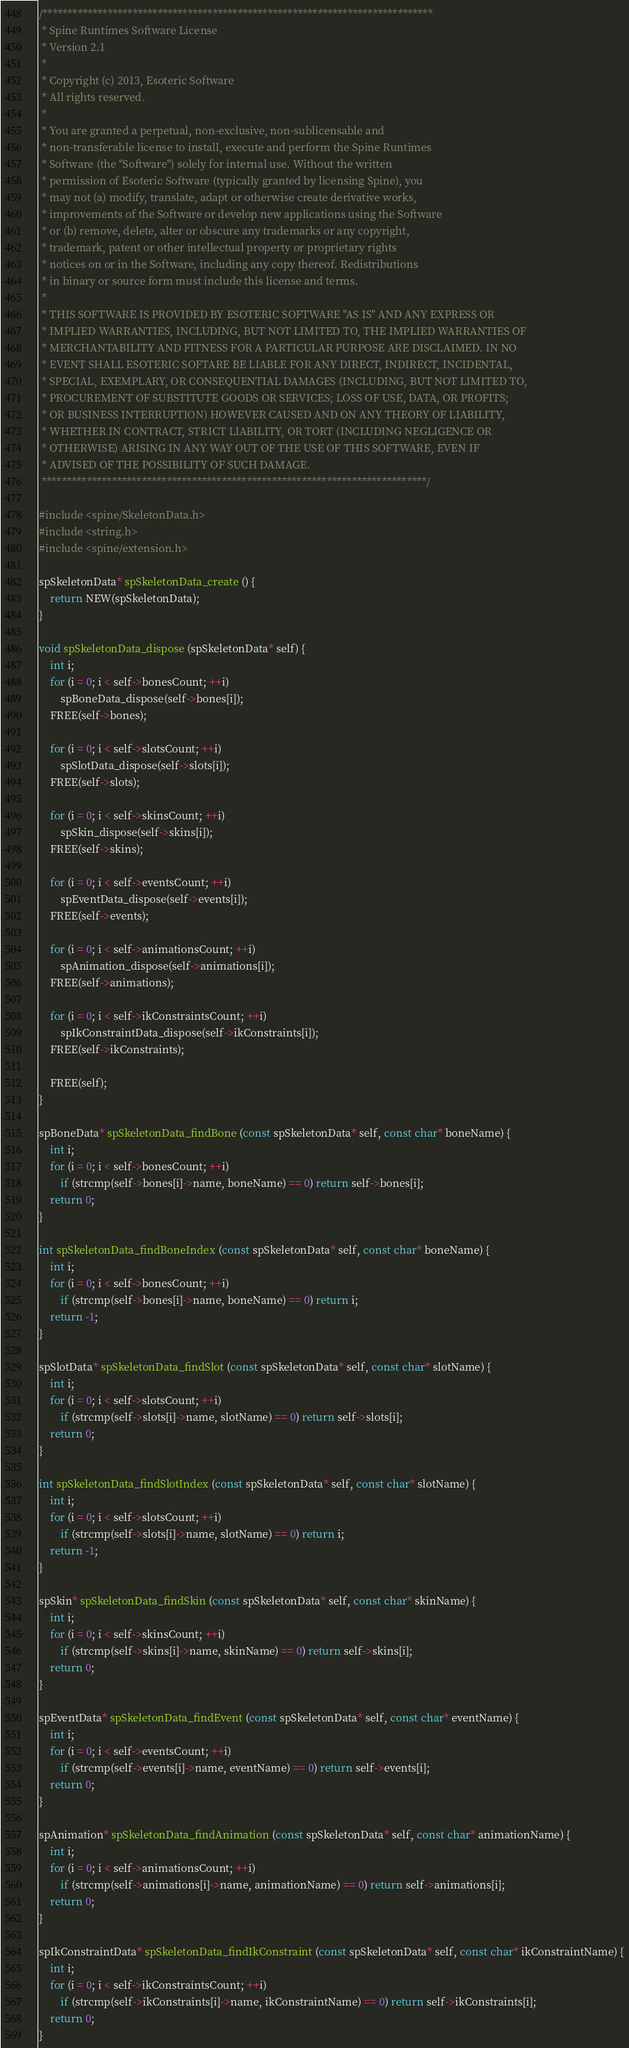Convert code to text. <code><loc_0><loc_0><loc_500><loc_500><_C_>/******************************************************************************
 * Spine Runtimes Software License
 * Version 2.1
 * 
 * Copyright (c) 2013, Esoteric Software
 * All rights reserved.
 * 
 * You are granted a perpetual, non-exclusive, non-sublicensable and
 * non-transferable license to install, execute and perform the Spine Runtimes
 * Software (the "Software") solely for internal use. Without the written
 * permission of Esoteric Software (typically granted by licensing Spine), you
 * may not (a) modify, translate, adapt or otherwise create derivative works,
 * improvements of the Software or develop new applications using the Software
 * or (b) remove, delete, alter or obscure any trademarks or any copyright,
 * trademark, patent or other intellectual property or proprietary rights
 * notices on or in the Software, including any copy thereof. Redistributions
 * in binary or source form must include this license and terms.
 * 
 * THIS SOFTWARE IS PROVIDED BY ESOTERIC SOFTWARE "AS IS" AND ANY EXPRESS OR
 * IMPLIED WARRANTIES, INCLUDING, BUT NOT LIMITED TO, THE IMPLIED WARRANTIES OF
 * MERCHANTABILITY AND FITNESS FOR A PARTICULAR PURPOSE ARE DISCLAIMED. IN NO
 * EVENT SHALL ESOTERIC SOFTARE BE LIABLE FOR ANY DIRECT, INDIRECT, INCIDENTAL,
 * SPECIAL, EXEMPLARY, OR CONSEQUENTIAL DAMAGES (INCLUDING, BUT NOT LIMITED TO,
 * PROCUREMENT OF SUBSTITUTE GOODS OR SERVICES; LOSS OF USE, DATA, OR PROFITS;
 * OR BUSINESS INTERRUPTION) HOWEVER CAUSED AND ON ANY THEORY OF LIABILITY,
 * WHETHER IN CONTRACT, STRICT LIABILITY, OR TORT (INCLUDING NEGLIGENCE OR
 * OTHERWISE) ARISING IN ANY WAY OUT OF THE USE OF THIS SOFTWARE, EVEN IF
 * ADVISED OF THE POSSIBILITY OF SUCH DAMAGE.
 *****************************************************************************/

#include <spine/SkeletonData.h>
#include <string.h>
#include <spine/extension.h>

spSkeletonData* spSkeletonData_create () {
	return NEW(spSkeletonData);
}

void spSkeletonData_dispose (spSkeletonData* self) {
	int i;
	for (i = 0; i < self->bonesCount; ++i)
		spBoneData_dispose(self->bones[i]);
	FREE(self->bones);

	for (i = 0; i < self->slotsCount; ++i)
		spSlotData_dispose(self->slots[i]);
	FREE(self->slots);

	for (i = 0; i < self->skinsCount; ++i)
		spSkin_dispose(self->skins[i]);
	FREE(self->skins);

	for (i = 0; i < self->eventsCount; ++i)
		spEventData_dispose(self->events[i]);
	FREE(self->events);

	for (i = 0; i < self->animationsCount; ++i)
		spAnimation_dispose(self->animations[i]);
	FREE(self->animations);

	for (i = 0; i < self->ikConstraintsCount; ++i)
		spIkConstraintData_dispose(self->ikConstraints[i]);
	FREE(self->ikConstraints);

	FREE(self);
}

spBoneData* spSkeletonData_findBone (const spSkeletonData* self, const char* boneName) {
	int i;
	for (i = 0; i < self->bonesCount; ++i)
		if (strcmp(self->bones[i]->name, boneName) == 0) return self->bones[i];
	return 0;
}

int spSkeletonData_findBoneIndex (const spSkeletonData* self, const char* boneName) {
	int i;
	for (i = 0; i < self->bonesCount; ++i)
		if (strcmp(self->bones[i]->name, boneName) == 0) return i;
	return -1;
}

spSlotData* spSkeletonData_findSlot (const spSkeletonData* self, const char* slotName) {
	int i;
	for (i = 0; i < self->slotsCount; ++i)
		if (strcmp(self->slots[i]->name, slotName) == 0) return self->slots[i];
	return 0;
}

int spSkeletonData_findSlotIndex (const spSkeletonData* self, const char* slotName) {
	int i;
	for (i = 0; i < self->slotsCount; ++i)
		if (strcmp(self->slots[i]->name, slotName) == 0) return i;
	return -1;
}

spSkin* spSkeletonData_findSkin (const spSkeletonData* self, const char* skinName) {
	int i;
	for (i = 0; i < self->skinsCount; ++i)
		if (strcmp(self->skins[i]->name, skinName) == 0) return self->skins[i];
	return 0;
}

spEventData* spSkeletonData_findEvent (const spSkeletonData* self, const char* eventName) {
	int i;
	for (i = 0; i < self->eventsCount; ++i)
		if (strcmp(self->events[i]->name, eventName) == 0) return self->events[i];
	return 0;
}

spAnimation* spSkeletonData_findAnimation (const spSkeletonData* self, const char* animationName) {
	int i;
	for (i = 0; i < self->animationsCount; ++i)
		if (strcmp(self->animations[i]->name, animationName) == 0) return self->animations[i];
	return 0;
}

spIkConstraintData* spSkeletonData_findIkConstraint (const spSkeletonData* self, const char* ikConstraintName) {
	int i;
	for (i = 0; i < self->ikConstraintsCount; ++i)
		if (strcmp(self->ikConstraints[i]->name, ikConstraintName) == 0) return self->ikConstraints[i];
	return 0;
}
</code> 